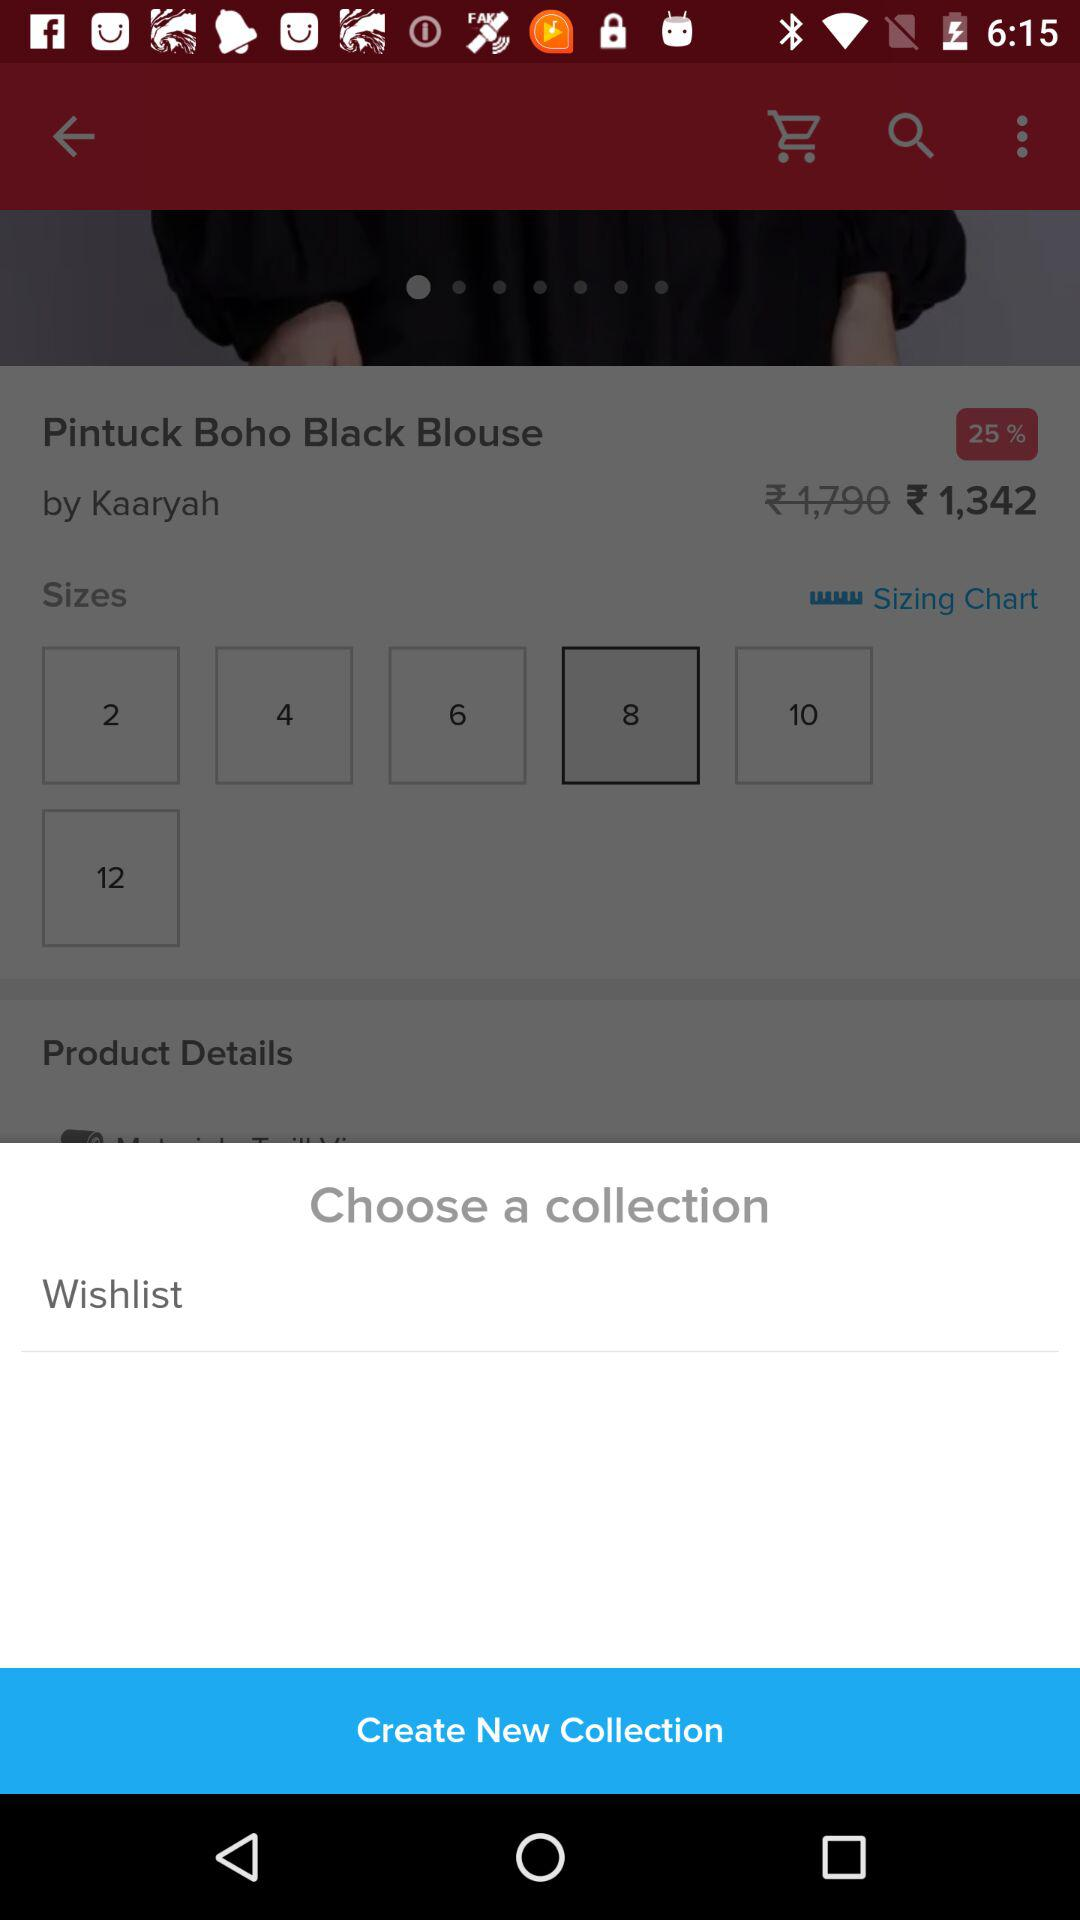What is the price of "Pintuck Boho Black Blouse" after discount? The price is ₹ 1,342. 